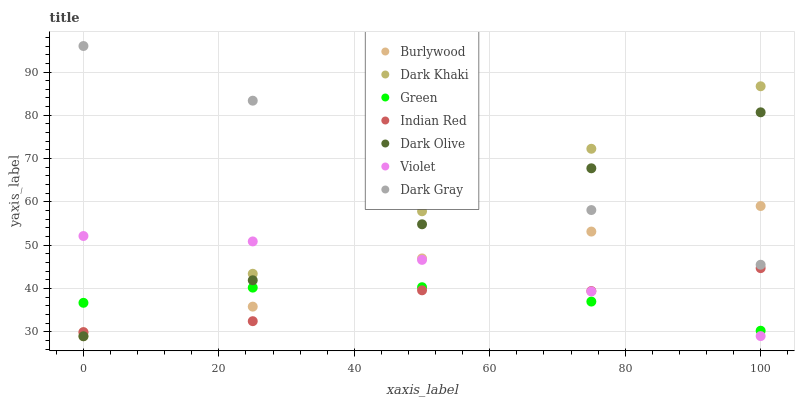Does Indian Red have the minimum area under the curve?
Answer yes or no. Yes. Does Dark Gray have the maximum area under the curve?
Answer yes or no. Yes. Does Burlywood have the minimum area under the curve?
Answer yes or no. No. Does Burlywood have the maximum area under the curve?
Answer yes or no. No. Is Dark Gray the smoothest?
Answer yes or no. Yes. Is Indian Red the roughest?
Answer yes or no. Yes. Is Burlywood the smoothest?
Answer yes or no. No. Is Burlywood the roughest?
Answer yes or no. No. Does Dark Olive have the lowest value?
Answer yes or no. Yes. Does Burlywood have the lowest value?
Answer yes or no. No. Does Dark Gray have the highest value?
Answer yes or no. Yes. Does Burlywood have the highest value?
Answer yes or no. No. Is Violet less than Dark Gray?
Answer yes or no. Yes. Is Dark Gray greater than Violet?
Answer yes or no. Yes. Does Green intersect Dark Khaki?
Answer yes or no. Yes. Is Green less than Dark Khaki?
Answer yes or no. No. Is Green greater than Dark Khaki?
Answer yes or no. No. Does Violet intersect Dark Gray?
Answer yes or no. No. 